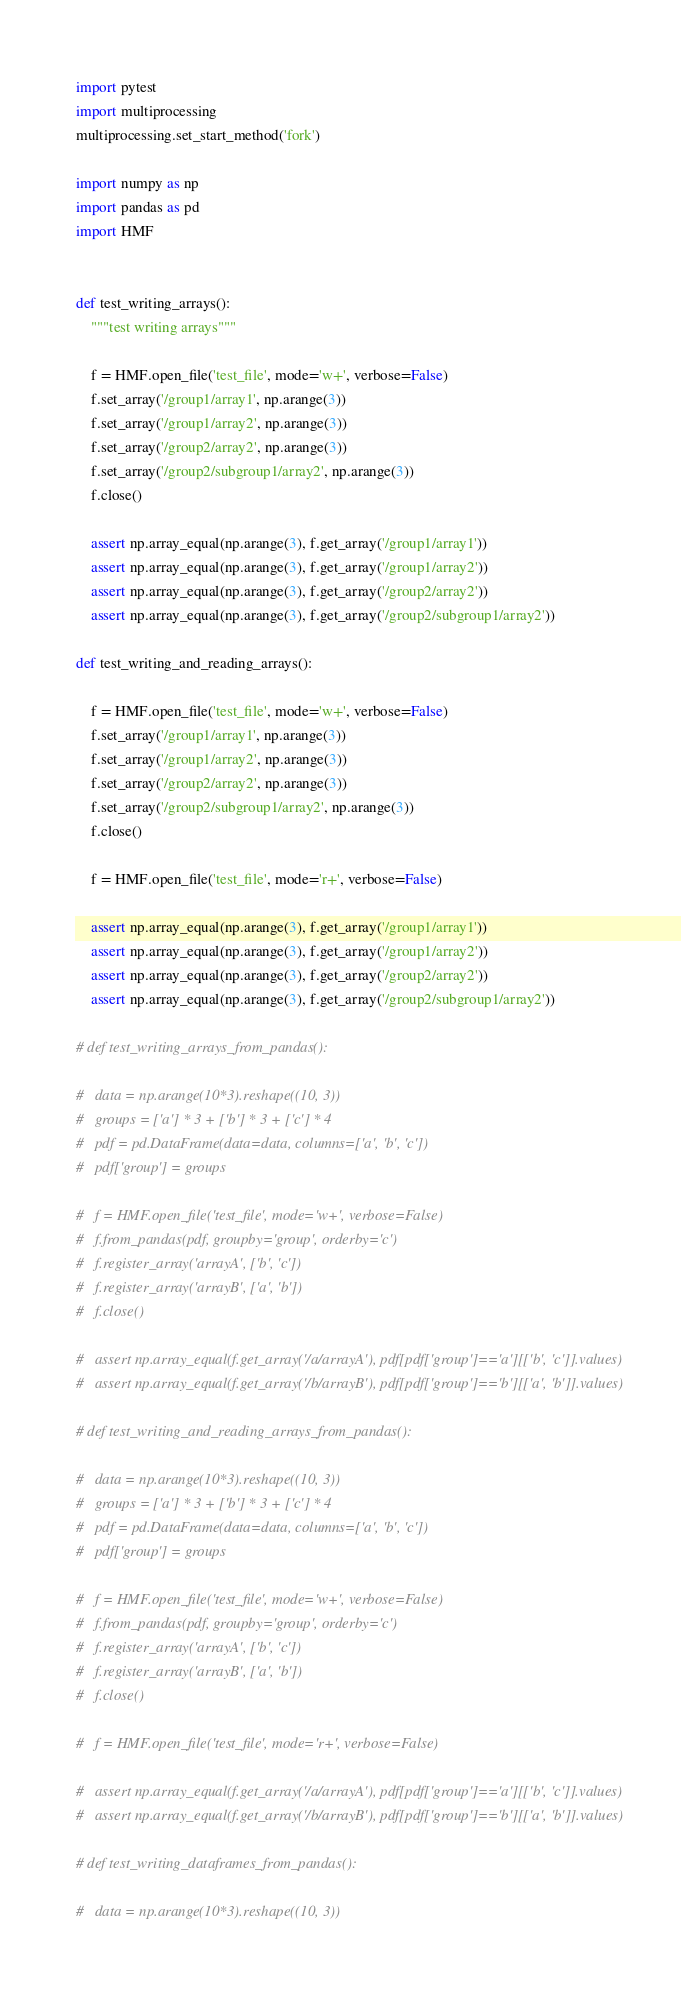<code> <loc_0><loc_0><loc_500><loc_500><_Python_>import pytest
import multiprocessing
multiprocessing.set_start_method('fork')

import numpy as np
import pandas as pd
import HMF


def test_writing_arrays():
	"""test writing arrays"""

	f = HMF.open_file('test_file', mode='w+', verbose=False)
	f.set_array('/group1/array1', np.arange(3))
	f.set_array('/group1/array2', np.arange(3))
	f.set_array('/group2/array2', np.arange(3))
	f.set_array('/group2/subgroup1/array2', np.arange(3))
	f.close()

	assert np.array_equal(np.arange(3), f.get_array('/group1/array1'))
	assert np.array_equal(np.arange(3), f.get_array('/group1/array2'))
	assert np.array_equal(np.arange(3), f.get_array('/group2/array2'))
	assert np.array_equal(np.arange(3), f.get_array('/group2/subgroup1/array2'))

def test_writing_and_reading_arrays():
	
	f = HMF.open_file('test_file', mode='w+', verbose=False)
	f.set_array('/group1/array1', np.arange(3))
	f.set_array('/group1/array2', np.arange(3))
	f.set_array('/group2/array2', np.arange(3))
	f.set_array('/group2/subgroup1/array2', np.arange(3))
	f.close()

	f = HMF.open_file('test_file', mode='r+', verbose=False)

	assert np.array_equal(np.arange(3), f.get_array('/group1/array1'))
	assert np.array_equal(np.arange(3), f.get_array('/group1/array2'))
	assert np.array_equal(np.arange(3), f.get_array('/group2/array2'))
	assert np.array_equal(np.arange(3), f.get_array('/group2/subgroup1/array2'))

# def test_writing_arrays_from_pandas():

# 	data = np.arange(10*3).reshape((10, 3))
# 	groups = ['a'] * 3 + ['b'] * 3 + ['c'] * 4
# 	pdf = pd.DataFrame(data=data, columns=['a', 'b', 'c'])
# 	pdf['group'] = groups

# 	f = HMF.open_file('test_file', mode='w+', verbose=False)
# 	f.from_pandas(pdf, groupby='group', orderby='c')
# 	f.register_array('arrayA', ['b', 'c'])
# 	f.register_array('arrayB', ['a', 'b'])
# 	f.close()

# 	assert np.array_equal(f.get_array('/a/arrayA'), pdf[pdf['group']=='a'][['b', 'c']].values)
# 	assert np.array_equal(f.get_array('/b/arrayB'), pdf[pdf['group']=='b'][['a', 'b']].values)

# def test_writing_and_reading_arrays_from_pandas():

# 	data = np.arange(10*3).reshape((10, 3))
# 	groups = ['a'] * 3 + ['b'] * 3 + ['c'] * 4
# 	pdf = pd.DataFrame(data=data, columns=['a', 'b', 'c'])
# 	pdf['group'] = groups

# 	f = HMF.open_file('test_file', mode='w+', verbose=False)
# 	f.from_pandas(pdf, groupby='group', orderby='c')
# 	f.register_array('arrayA', ['b', 'c'])
# 	f.register_array('arrayB', ['a', 'b'])
# 	f.close()

# 	f = HMF.open_file('test_file', mode='r+', verbose=False)

# 	assert np.array_equal(f.get_array('/a/arrayA'), pdf[pdf['group']=='a'][['b', 'c']].values)
# 	assert np.array_equal(f.get_array('/b/arrayB'), pdf[pdf['group']=='b'][['a', 'b']].values)

# def test_writing_dataframes_from_pandas():

# 	data = np.arange(10*3).reshape((10, 3))</code> 